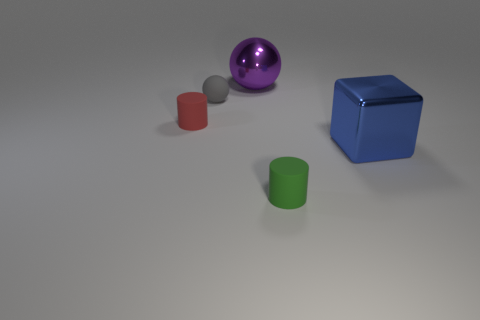What could these objects represent if we were to view this as a symbolic image? If these objects were interpreted symbolically, the shiny ball could represent something rare or valuable due to its lustrous finish and standout color. The red cylinder might signify stability or uniformity because of its symmetrical shape. The blue cube could symbolize structure and order, while the green cylinder might be associated with growth or sustainability. Each object's placement and color could imply a particular theme or idea. 